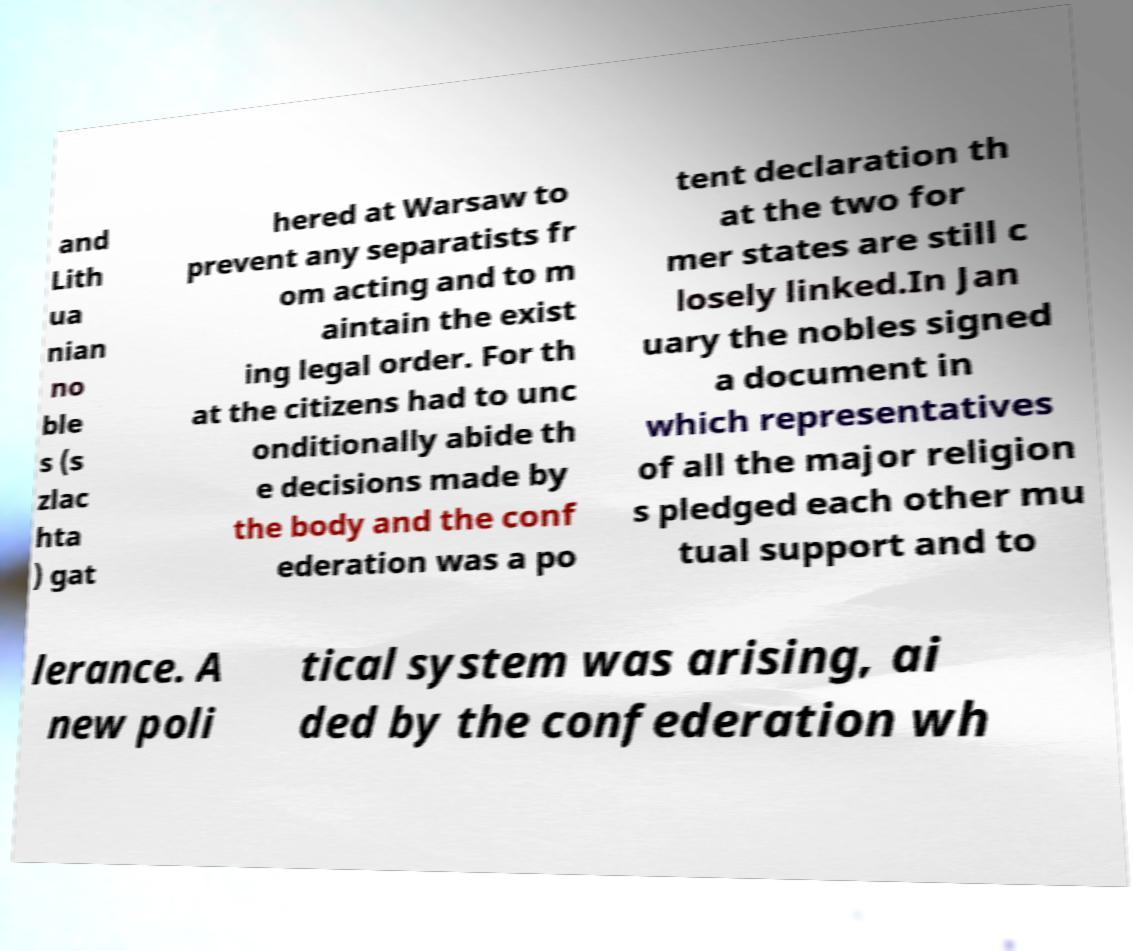I need the written content from this picture converted into text. Can you do that? and Lith ua nian no ble s (s zlac hta ) gat hered at Warsaw to prevent any separatists fr om acting and to m aintain the exist ing legal order. For th at the citizens had to unc onditionally abide th e decisions made by the body and the conf ederation was a po tent declaration th at the two for mer states are still c losely linked.In Jan uary the nobles signed a document in which representatives of all the major religion s pledged each other mu tual support and to lerance. A new poli tical system was arising, ai ded by the confederation wh 